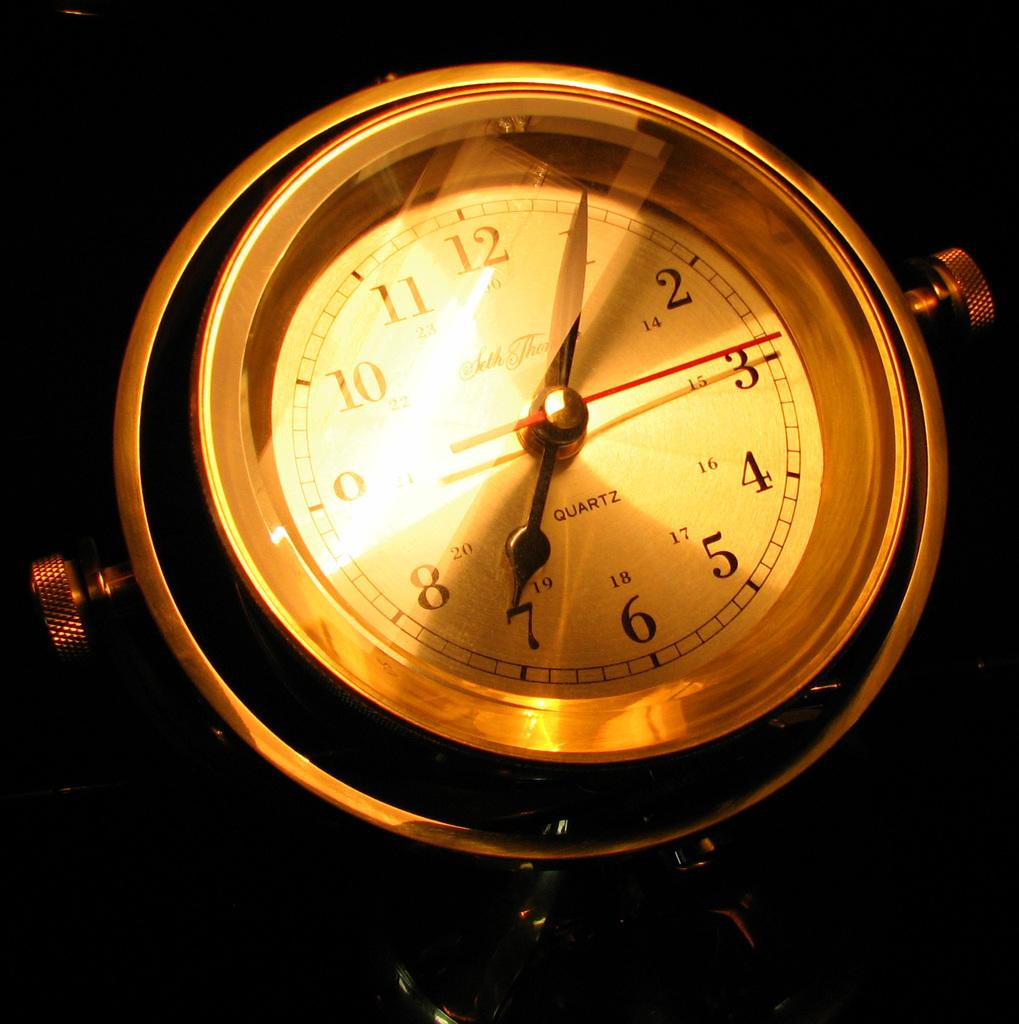<image>
Offer a succinct explanation of the picture presented. the number 12 is on the face of a clock 